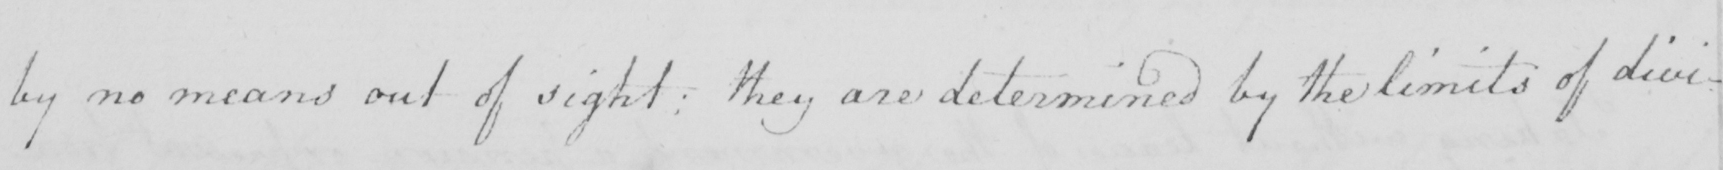What is written in this line of handwriting? by no means out of sight :  they are determined by the limits of div- 